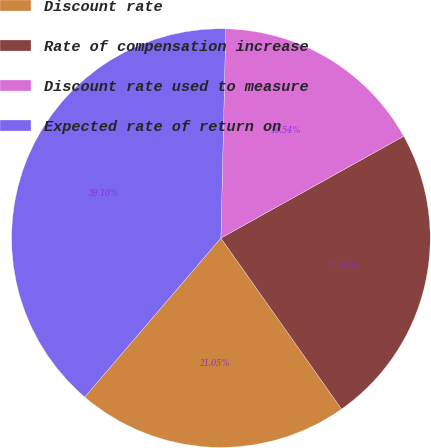<chart> <loc_0><loc_0><loc_500><loc_500><pie_chart><fcel>Discount rate<fcel>Rate of compensation increase<fcel>Discount rate used to measure<fcel>Expected rate of return on<nl><fcel>21.05%<fcel>23.31%<fcel>16.54%<fcel>39.1%<nl></chart> 